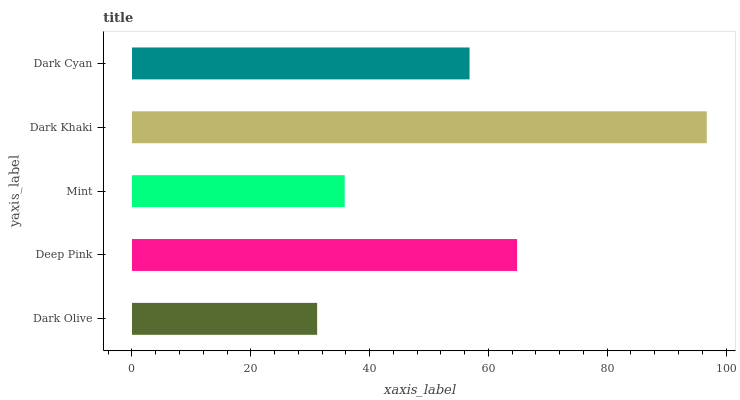Is Dark Olive the minimum?
Answer yes or no. Yes. Is Dark Khaki the maximum?
Answer yes or no. Yes. Is Deep Pink the minimum?
Answer yes or no. No. Is Deep Pink the maximum?
Answer yes or no. No. Is Deep Pink greater than Dark Olive?
Answer yes or no. Yes. Is Dark Olive less than Deep Pink?
Answer yes or no. Yes. Is Dark Olive greater than Deep Pink?
Answer yes or no. No. Is Deep Pink less than Dark Olive?
Answer yes or no. No. Is Dark Cyan the high median?
Answer yes or no. Yes. Is Dark Cyan the low median?
Answer yes or no. Yes. Is Dark Olive the high median?
Answer yes or no. No. Is Dark Olive the low median?
Answer yes or no. No. 